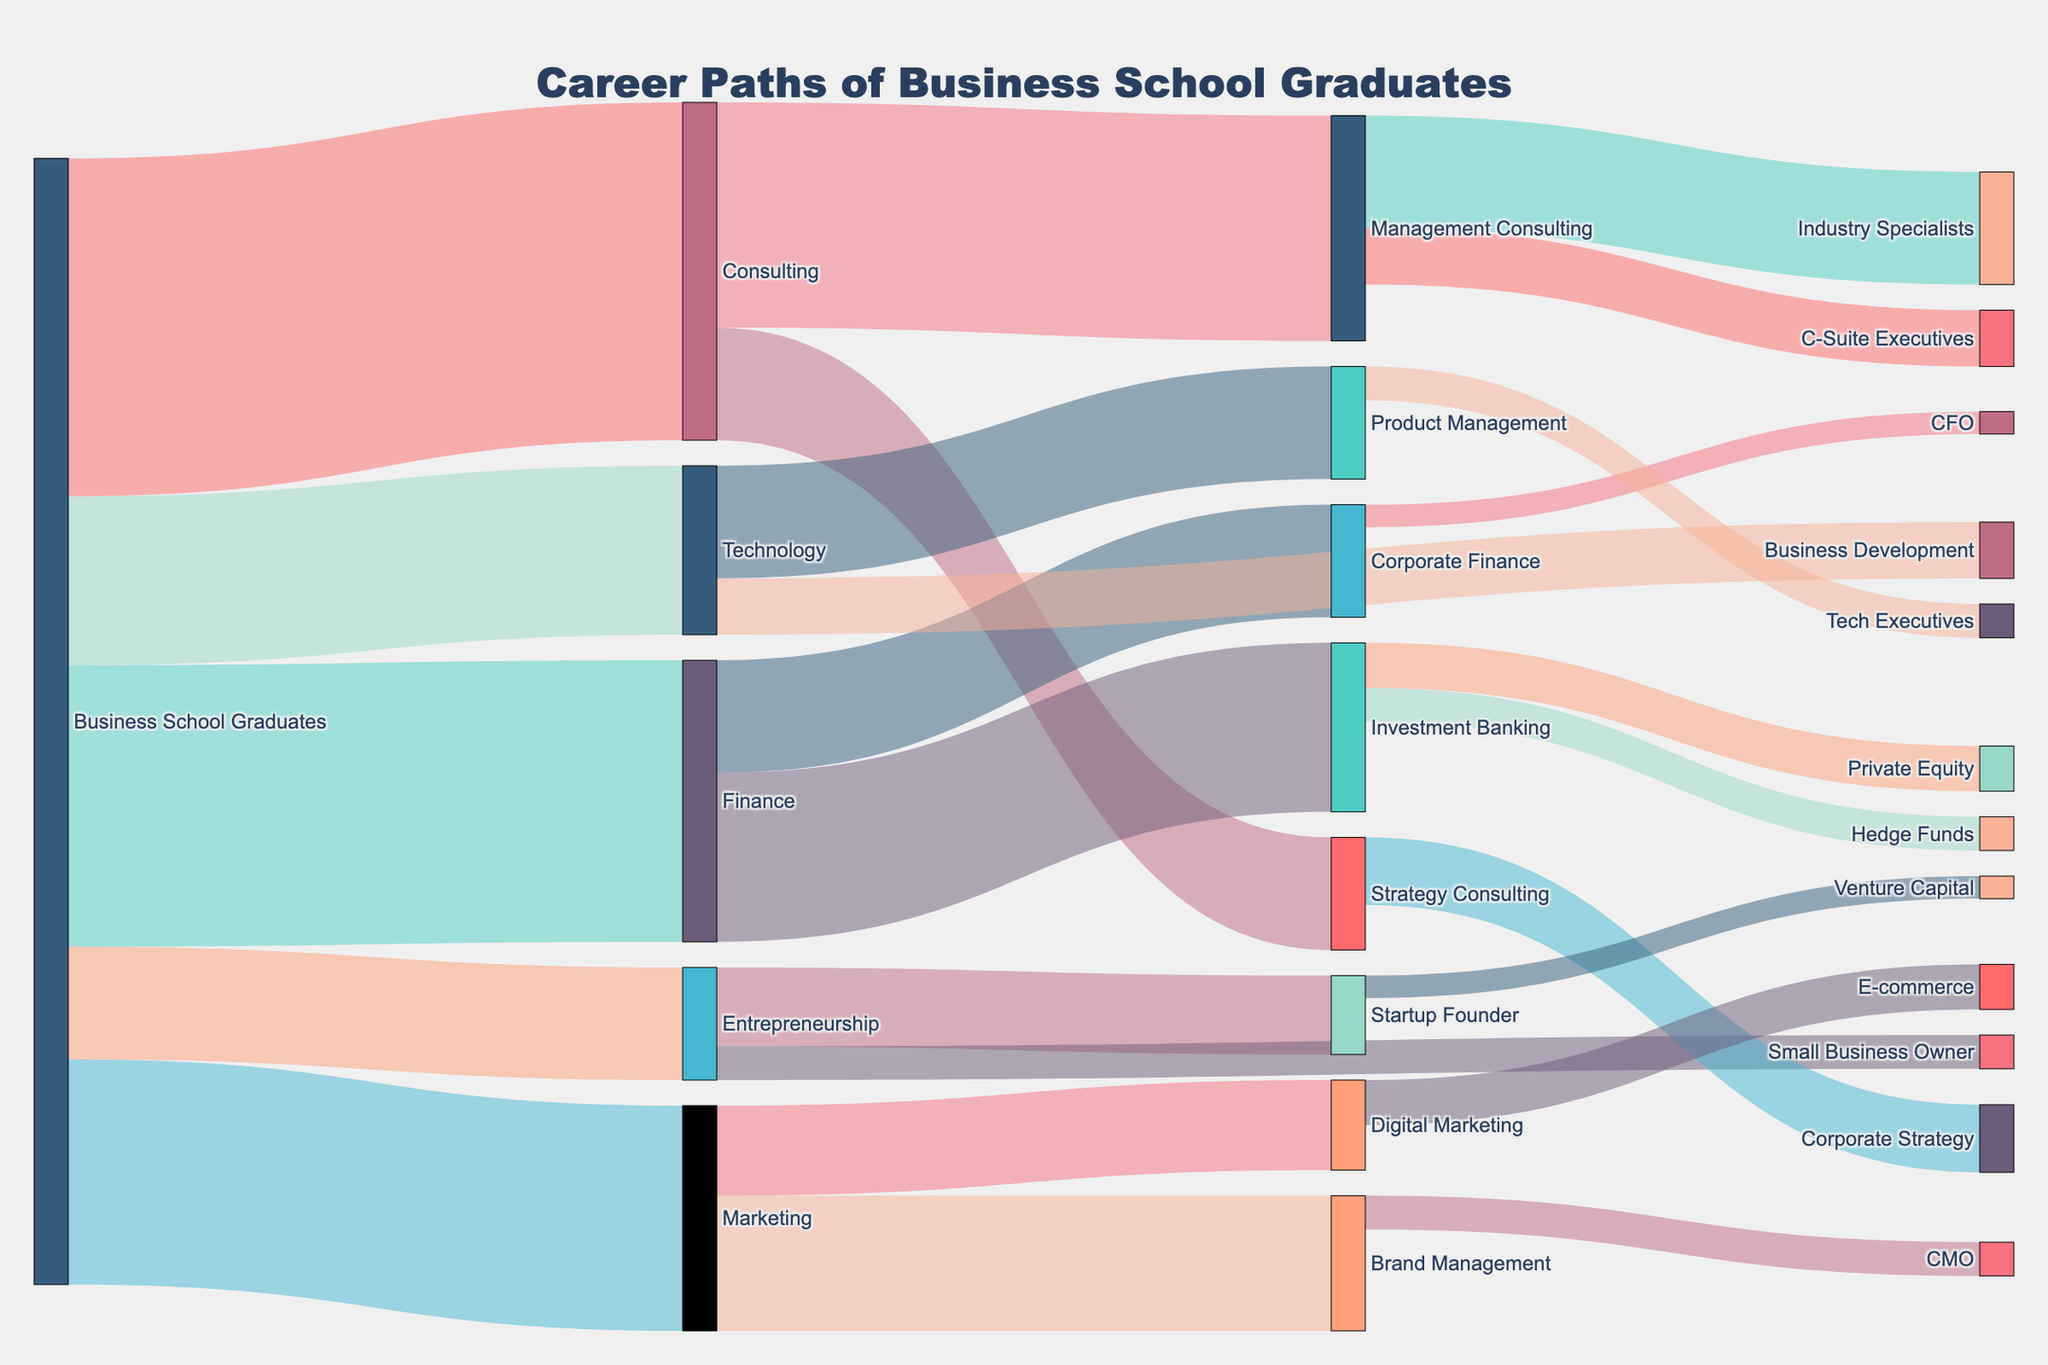What's the title of the figure? The title of the figure is typically displayed prominently at the top, centering the focus on the main purpose of the diagram.
Answer: Career Paths of Business School Graduates How many graduates initially pursued a career in Finance? Locate the flow from "Business School Graduates" to "Finance"; the value associated with this link shows the number of graduates.
Answer: 250 Which career path in Marketing attracted the most graduates? Examine the links flowing from "Marketing"; compare the values for "Brand Management" and "Digital Marketing" to determine which is higher.
Answer: Brand Management How many graduates transitioned into Strategy Consulting from Consulting? Check the link starting from "Consulting" and ending at "Strategy Consulting"; the value along this path indicates the number of graduates.
Answer: 100 What total number of graduates transitioned into the role of C-Suite Executives from Management Consulting? Locate the link from "Management Consulting" to "C-Suite Executives" and note the value.
Answer: 50 How many graduates moved to Corporate Strategy from Strategy Consulting compared to those moving to Industry Specialists from Management Consulting? Identify and sum the values for transitions from "Strategy Consulting" to "Corporate Strategy" and from "Management Consulting" to "Industry Specialists". Compare these sums.
Answer: 60 vs 100 Which industry received the smallest inflow of Business School Graduates? Look at the initial flows from "Business School Graduates" to various industries; identify the smallest value.
Answer: Entrepreneurship How many graduates initially went into Technology and then moved into Business Development? Track the flow from "Business School Graduates" to "Technology" and then to "Business Development"; the value of the second link indicates this number.
Answer: 50 What is the total number of Business School Graduates who eventually became executives (C-Suite Executives, Tech Executives, CFO, or CMO)? Sum the values for graduates transitioning to these roles: "C-Suite Executives", "Tech Executives", "CFO", and "CMO".
Answer: 50 + 30 + 20 + 30 = 130 